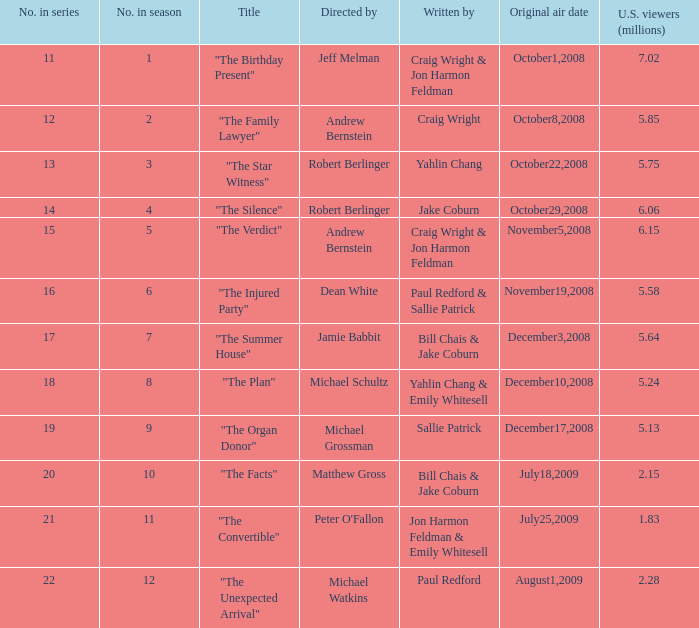What is the debut air date of the episode directed by jeff melman? October1,2008. 